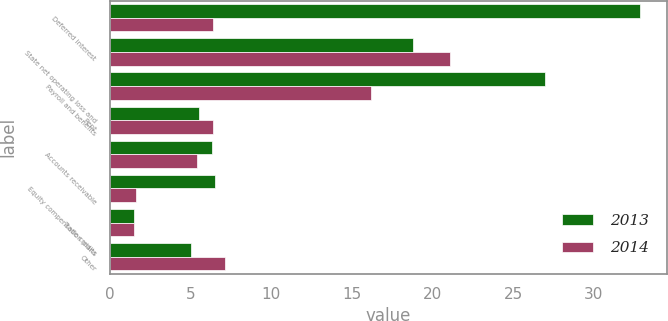<chart> <loc_0><loc_0><loc_500><loc_500><stacked_bar_chart><ecel><fcel>Deferred interest<fcel>State net operating loss and<fcel>Payroll and benefits<fcel>Rent<fcel>Accounts receivable<fcel>Equity compensation plans<fcel>Trade credits<fcel>Other<nl><fcel>2013<fcel>32.9<fcel>18.8<fcel>27<fcel>5.5<fcel>6.3<fcel>6.5<fcel>1.5<fcel>5<nl><fcel>2014<fcel>6.4<fcel>21.1<fcel>16.2<fcel>6.4<fcel>5.4<fcel>1.6<fcel>1.5<fcel>7.1<nl></chart> 